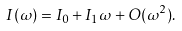<formula> <loc_0><loc_0><loc_500><loc_500>I ( \omega ) = I _ { 0 } + I _ { 1 } \omega + O ( \omega ^ { 2 } ) .</formula> 